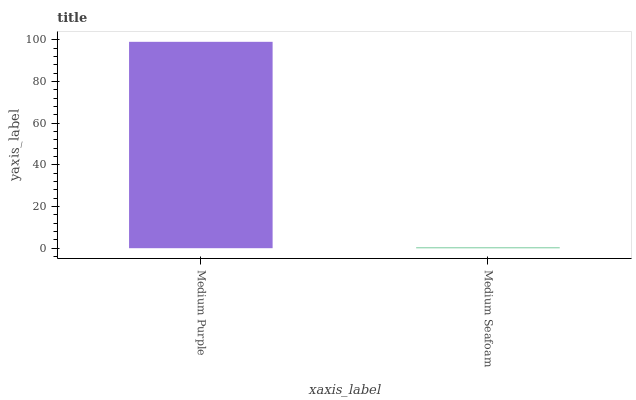Is Medium Seafoam the minimum?
Answer yes or no. Yes. Is Medium Purple the maximum?
Answer yes or no. Yes. Is Medium Seafoam the maximum?
Answer yes or no. No. Is Medium Purple greater than Medium Seafoam?
Answer yes or no. Yes. Is Medium Seafoam less than Medium Purple?
Answer yes or no. Yes. Is Medium Seafoam greater than Medium Purple?
Answer yes or no. No. Is Medium Purple less than Medium Seafoam?
Answer yes or no. No. Is Medium Purple the high median?
Answer yes or no. Yes. Is Medium Seafoam the low median?
Answer yes or no. Yes. Is Medium Seafoam the high median?
Answer yes or no. No. Is Medium Purple the low median?
Answer yes or no. No. 